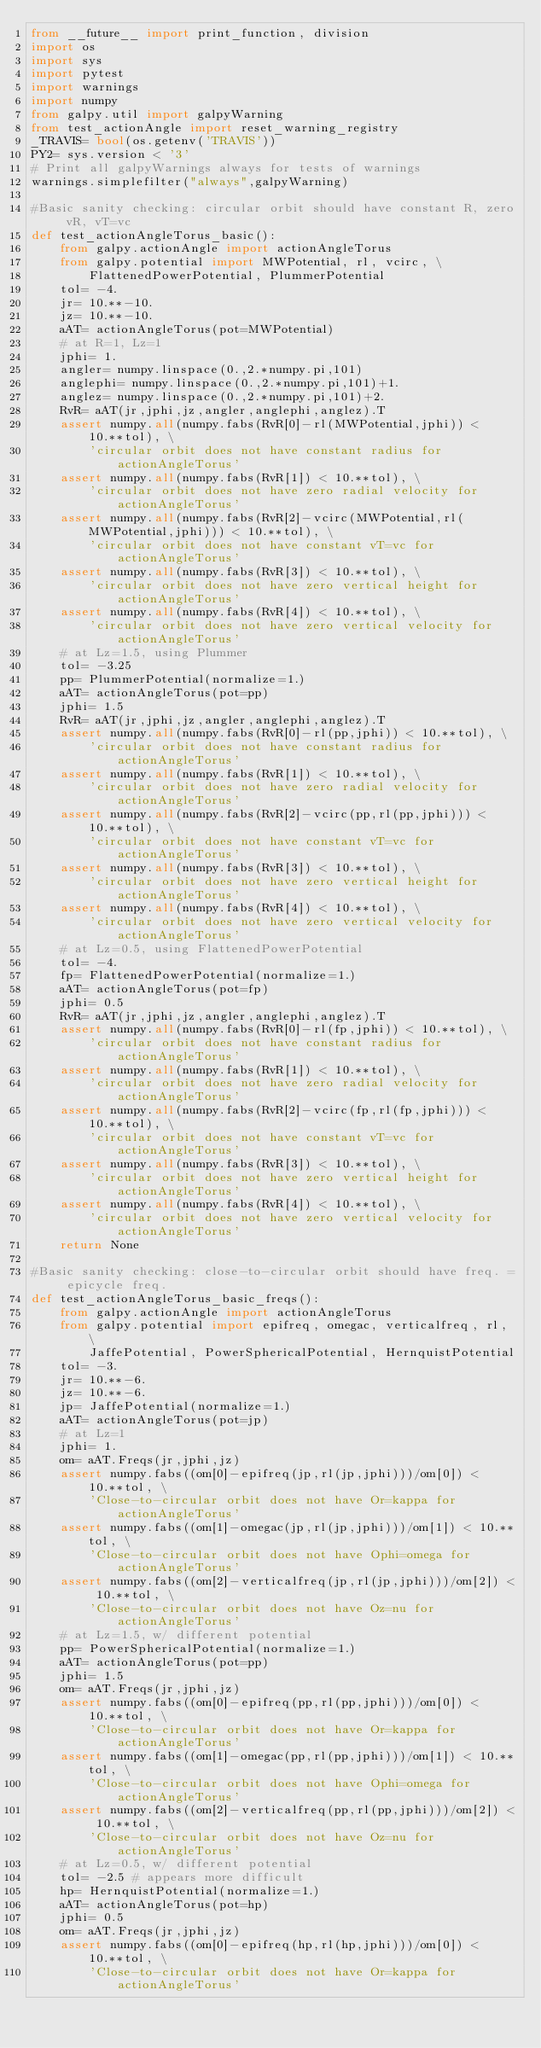<code> <loc_0><loc_0><loc_500><loc_500><_Python_>from __future__ import print_function, division
import os
import sys
import pytest
import warnings
import numpy
from galpy.util import galpyWarning
from test_actionAngle import reset_warning_registry
_TRAVIS= bool(os.getenv('TRAVIS'))
PY2= sys.version < '3'
# Print all galpyWarnings always for tests of warnings
warnings.simplefilter("always",galpyWarning)

#Basic sanity checking: circular orbit should have constant R, zero vR, vT=vc
def test_actionAngleTorus_basic():
    from galpy.actionAngle import actionAngleTorus
    from galpy.potential import MWPotential, rl, vcirc, \
        FlattenedPowerPotential, PlummerPotential
    tol= -4.
    jr= 10.**-10.
    jz= 10.**-10.
    aAT= actionAngleTorus(pot=MWPotential)
    # at R=1, Lz=1
    jphi= 1.
    angler= numpy.linspace(0.,2.*numpy.pi,101)
    anglephi= numpy.linspace(0.,2.*numpy.pi,101)+1.
    anglez= numpy.linspace(0.,2.*numpy.pi,101)+2.
    RvR= aAT(jr,jphi,jz,angler,anglephi,anglez).T
    assert numpy.all(numpy.fabs(RvR[0]-rl(MWPotential,jphi)) < 10.**tol), \
        'circular orbit does not have constant radius for actionAngleTorus'
    assert numpy.all(numpy.fabs(RvR[1]) < 10.**tol), \
        'circular orbit does not have zero radial velocity for actionAngleTorus'
    assert numpy.all(numpy.fabs(RvR[2]-vcirc(MWPotential,rl(MWPotential,jphi))) < 10.**tol), \
        'circular orbit does not have constant vT=vc for actionAngleTorus'
    assert numpy.all(numpy.fabs(RvR[3]) < 10.**tol), \
        'circular orbit does not have zero vertical height for actionAngleTorus'
    assert numpy.all(numpy.fabs(RvR[4]) < 10.**tol), \
        'circular orbit does not have zero vertical velocity for actionAngleTorus'
    # at Lz=1.5, using Plummer
    tol= -3.25
    pp= PlummerPotential(normalize=1.)
    aAT= actionAngleTorus(pot=pp)
    jphi= 1.5
    RvR= aAT(jr,jphi,jz,angler,anglephi,anglez).T
    assert numpy.all(numpy.fabs(RvR[0]-rl(pp,jphi)) < 10.**tol), \
        'circular orbit does not have constant radius for actionAngleTorus'
    assert numpy.all(numpy.fabs(RvR[1]) < 10.**tol), \
        'circular orbit does not have zero radial velocity for actionAngleTorus'
    assert numpy.all(numpy.fabs(RvR[2]-vcirc(pp,rl(pp,jphi))) < 10.**tol), \
        'circular orbit does not have constant vT=vc for actionAngleTorus'
    assert numpy.all(numpy.fabs(RvR[3]) < 10.**tol), \
        'circular orbit does not have zero vertical height for actionAngleTorus'
    assert numpy.all(numpy.fabs(RvR[4]) < 10.**tol), \
        'circular orbit does not have zero vertical velocity for actionAngleTorus'
    # at Lz=0.5, using FlattenedPowerPotential
    tol= -4.
    fp= FlattenedPowerPotential(normalize=1.)
    aAT= actionAngleTorus(pot=fp)
    jphi= 0.5
    RvR= aAT(jr,jphi,jz,angler,anglephi,anglez).T
    assert numpy.all(numpy.fabs(RvR[0]-rl(fp,jphi)) < 10.**tol), \
        'circular orbit does not have constant radius for actionAngleTorus'
    assert numpy.all(numpy.fabs(RvR[1]) < 10.**tol), \
        'circular orbit does not have zero radial velocity for actionAngleTorus'
    assert numpy.all(numpy.fabs(RvR[2]-vcirc(fp,rl(fp,jphi))) < 10.**tol), \
        'circular orbit does not have constant vT=vc for actionAngleTorus'
    assert numpy.all(numpy.fabs(RvR[3]) < 10.**tol), \
        'circular orbit does not have zero vertical height for actionAngleTorus'
    assert numpy.all(numpy.fabs(RvR[4]) < 10.**tol), \
        'circular orbit does not have zero vertical velocity for actionAngleTorus'
    return None

#Basic sanity checking: close-to-circular orbit should have freq. = epicycle freq.
def test_actionAngleTorus_basic_freqs():
    from galpy.actionAngle import actionAngleTorus
    from galpy.potential import epifreq, omegac, verticalfreq, rl, \
        JaffePotential, PowerSphericalPotential, HernquistPotential
    tol= -3.
    jr= 10.**-6.
    jz= 10.**-6.
    jp= JaffePotential(normalize=1.)
    aAT= actionAngleTorus(pot=jp)
    # at Lz=1
    jphi= 1.
    om= aAT.Freqs(jr,jphi,jz)
    assert numpy.fabs((om[0]-epifreq(jp,rl(jp,jphi)))/om[0]) < 10.**tol, \
        'Close-to-circular orbit does not have Or=kappa for actionAngleTorus'
    assert numpy.fabs((om[1]-omegac(jp,rl(jp,jphi)))/om[1]) < 10.**tol, \
        'Close-to-circular orbit does not have Ophi=omega for actionAngleTorus'
    assert numpy.fabs((om[2]-verticalfreq(jp,rl(jp,jphi)))/om[2]) < 10.**tol, \
        'Close-to-circular orbit does not have Oz=nu for actionAngleTorus'
    # at Lz=1.5, w/ different potential
    pp= PowerSphericalPotential(normalize=1.)
    aAT= actionAngleTorus(pot=pp)
    jphi= 1.5
    om= aAT.Freqs(jr,jphi,jz)
    assert numpy.fabs((om[0]-epifreq(pp,rl(pp,jphi)))/om[0]) < 10.**tol, \
        'Close-to-circular orbit does not have Or=kappa for actionAngleTorus'
    assert numpy.fabs((om[1]-omegac(pp,rl(pp,jphi)))/om[1]) < 10.**tol, \
        'Close-to-circular orbit does not have Ophi=omega for actionAngleTorus'
    assert numpy.fabs((om[2]-verticalfreq(pp,rl(pp,jphi)))/om[2]) < 10.**tol, \
        'Close-to-circular orbit does not have Oz=nu for actionAngleTorus'
    # at Lz=0.5, w/ different potential
    tol= -2.5 # appears more difficult
    hp= HernquistPotential(normalize=1.)
    aAT= actionAngleTorus(pot=hp)
    jphi= 0.5
    om= aAT.Freqs(jr,jphi,jz)
    assert numpy.fabs((om[0]-epifreq(hp,rl(hp,jphi)))/om[0]) < 10.**tol, \
        'Close-to-circular orbit does not have Or=kappa for actionAngleTorus'</code> 